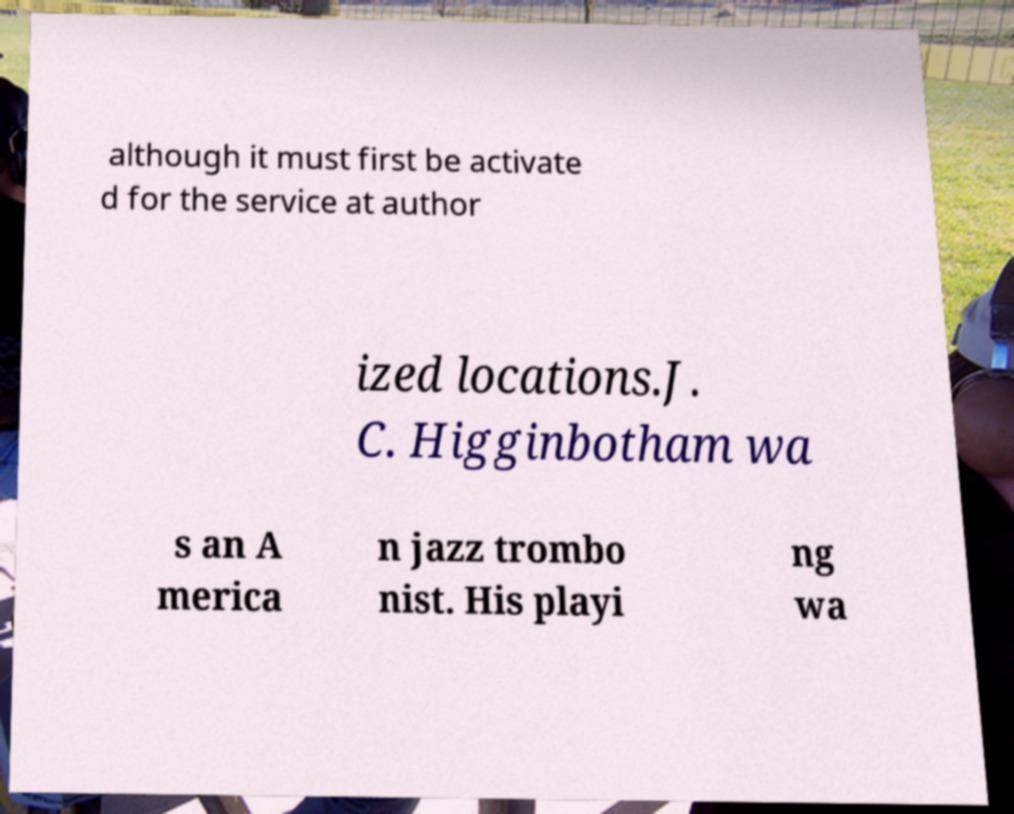Please identify and transcribe the text found in this image. although it must first be activate d for the service at author ized locations.J. C. Higginbotham wa s an A merica n jazz trombo nist. His playi ng wa 